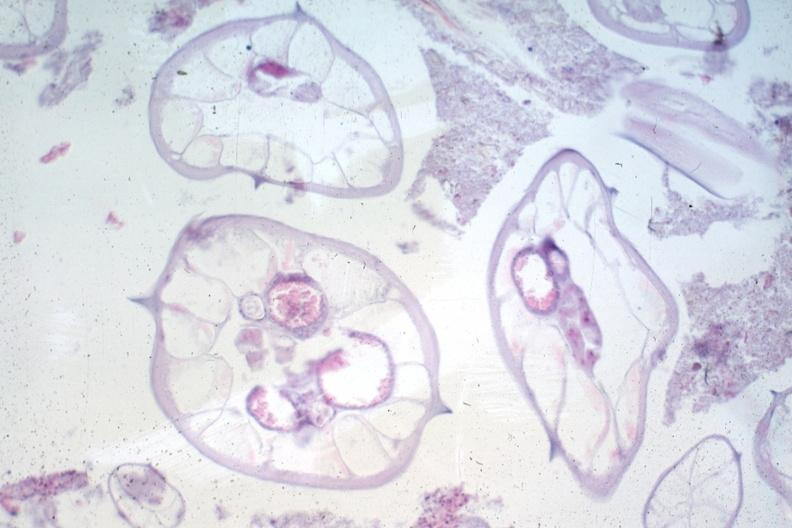s umbilical cord present?
Answer the question using a single word or phrase. No 